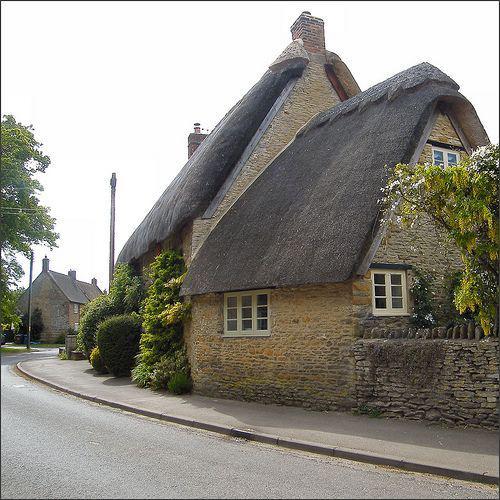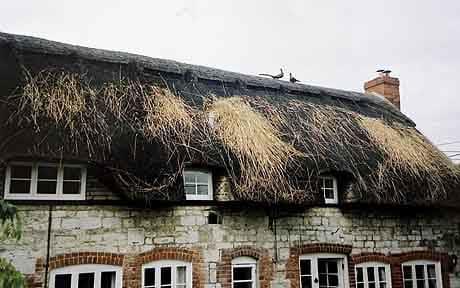The first image is the image on the left, the second image is the image on the right. Given the left and right images, does the statement "A road is seen to the left of the building in one image and not in the other." hold true? Answer yes or no. Yes. 